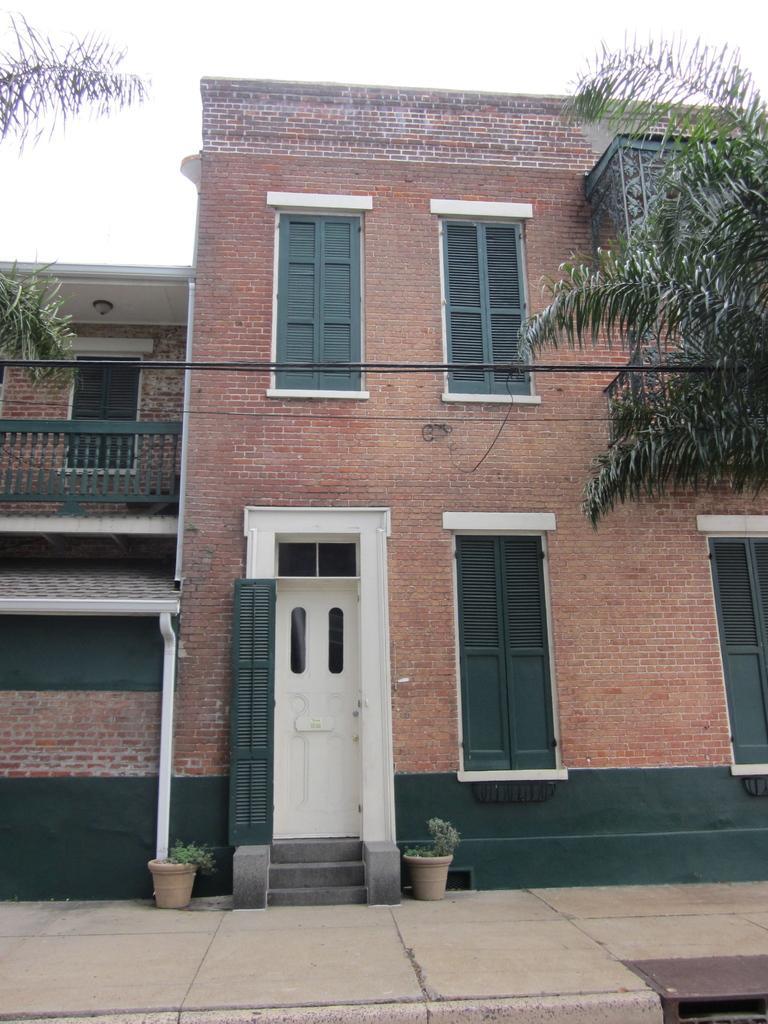Could you give a brief overview of what you see in this image? In this image there is a building. In front of the building there are trees and plants. In the background of the image there is sky. 